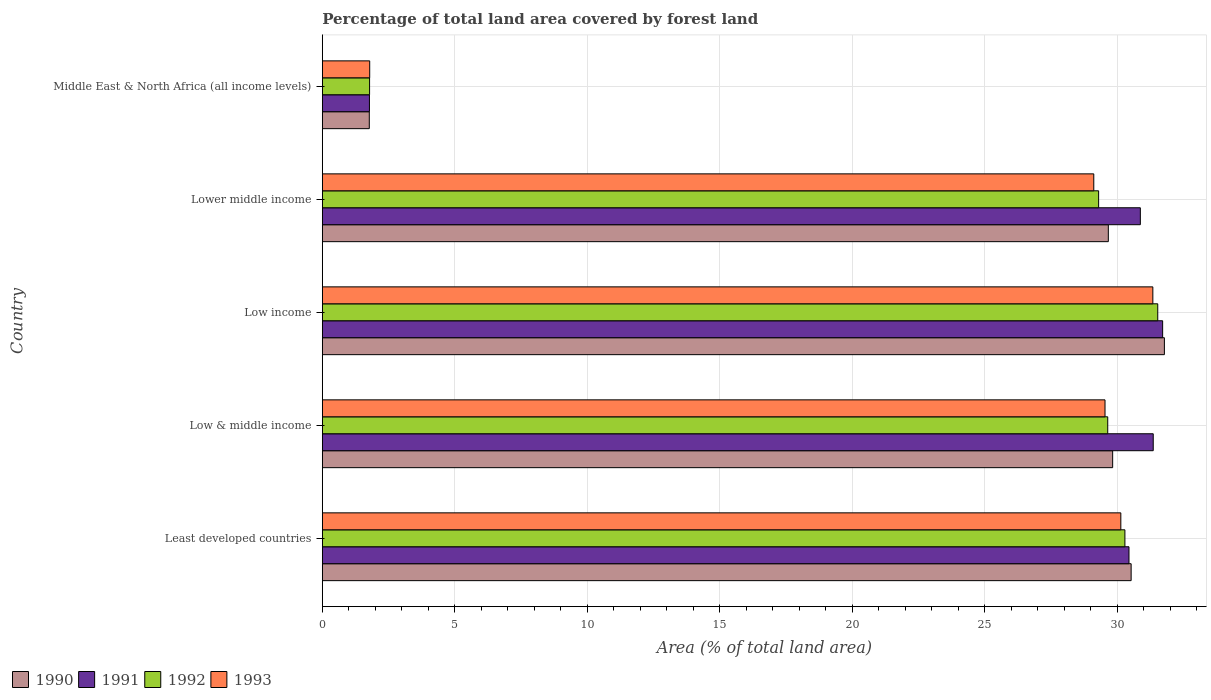Are the number of bars per tick equal to the number of legend labels?
Provide a short and direct response. Yes. Are the number of bars on each tick of the Y-axis equal?
Provide a succinct answer. Yes. How many bars are there on the 4th tick from the top?
Ensure brevity in your answer.  4. How many bars are there on the 3rd tick from the bottom?
Offer a terse response. 4. What is the label of the 5th group of bars from the top?
Your answer should be compact. Least developed countries. In how many cases, is the number of bars for a given country not equal to the number of legend labels?
Offer a terse response. 0. What is the percentage of forest land in 1990 in Low income?
Make the answer very short. 31.79. Across all countries, what is the maximum percentage of forest land in 1991?
Offer a very short reply. 31.72. Across all countries, what is the minimum percentage of forest land in 1993?
Offer a very short reply. 1.79. In which country was the percentage of forest land in 1990 maximum?
Your response must be concise. Low income. In which country was the percentage of forest land in 1990 minimum?
Offer a very short reply. Middle East & North Africa (all income levels). What is the total percentage of forest land in 1990 in the graph?
Offer a very short reply. 123.6. What is the difference between the percentage of forest land in 1993 in Least developed countries and that in Low & middle income?
Keep it short and to the point. 0.6. What is the difference between the percentage of forest land in 1993 in Low income and the percentage of forest land in 1991 in Low & middle income?
Make the answer very short. -0.01. What is the average percentage of forest land in 1992 per country?
Keep it short and to the point. 24.51. What is the difference between the percentage of forest land in 1993 and percentage of forest land in 1990 in Middle East & North Africa (all income levels)?
Make the answer very short. 0.02. In how many countries, is the percentage of forest land in 1993 greater than 29 %?
Provide a short and direct response. 4. What is the ratio of the percentage of forest land in 1991 in Low & middle income to that in Low income?
Offer a very short reply. 0.99. Is the difference between the percentage of forest land in 1993 in Least developed countries and Middle East & North Africa (all income levels) greater than the difference between the percentage of forest land in 1990 in Least developed countries and Middle East & North Africa (all income levels)?
Keep it short and to the point. No. What is the difference between the highest and the second highest percentage of forest land in 1990?
Give a very brief answer. 1.25. What is the difference between the highest and the lowest percentage of forest land in 1991?
Make the answer very short. 29.94. Is the sum of the percentage of forest land in 1991 in Low & middle income and Lower middle income greater than the maximum percentage of forest land in 1993 across all countries?
Your response must be concise. Yes. Is it the case that in every country, the sum of the percentage of forest land in 1990 and percentage of forest land in 1992 is greater than the sum of percentage of forest land in 1993 and percentage of forest land in 1991?
Your response must be concise. No. What does the 2nd bar from the bottom in Middle East & North Africa (all income levels) represents?
Offer a terse response. 1991. Is it the case that in every country, the sum of the percentage of forest land in 1991 and percentage of forest land in 1990 is greater than the percentage of forest land in 1992?
Offer a very short reply. Yes. How many bars are there?
Offer a terse response. 20. Are all the bars in the graph horizontal?
Your response must be concise. Yes. What is the difference between two consecutive major ticks on the X-axis?
Keep it short and to the point. 5. Are the values on the major ticks of X-axis written in scientific E-notation?
Your answer should be compact. No. Does the graph contain any zero values?
Make the answer very short. No. Does the graph contain grids?
Ensure brevity in your answer.  Yes. How are the legend labels stacked?
Give a very brief answer. Horizontal. What is the title of the graph?
Ensure brevity in your answer.  Percentage of total land area covered by forest land. Does "1980" appear as one of the legend labels in the graph?
Your response must be concise. No. What is the label or title of the X-axis?
Provide a succinct answer. Area (% of total land area). What is the Area (% of total land area) of 1990 in Least developed countries?
Make the answer very short. 30.53. What is the Area (% of total land area) in 1991 in Least developed countries?
Offer a terse response. 30.45. What is the Area (% of total land area) of 1992 in Least developed countries?
Provide a short and direct response. 30.3. What is the Area (% of total land area) in 1993 in Least developed countries?
Give a very brief answer. 30.14. What is the Area (% of total land area) of 1990 in Low & middle income?
Your answer should be very brief. 29.83. What is the Area (% of total land area) in 1991 in Low & middle income?
Offer a terse response. 31.37. What is the Area (% of total land area) of 1992 in Low & middle income?
Offer a terse response. 29.65. What is the Area (% of total land area) of 1993 in Low & middle income?
Your answer should be very brief. 29.55. What is the Area (% of total land area) in 1990 in Low income?
Your response must be concise. 31.79. What is the Area (% of total land area) of 1991 in Low income?
Give a very brief answer. 31.72. What is the Area (% of total land area) of 1992 in Low income?
Your answer should be very brief. 31.54. What is the Area (% of total land area) in 1993 in Low income?
Keep it short and to the point. 31.35. What is the Area (% of total land area) of 1990 in Lower middle income?
Offer a very short reply. 29.67. What is the Area (% of total land area) of 1991 in Lower middle income?
Make the answer very short. 30.88. What is the Area (% of total land area) of 1992 in Lower middle income?
Provide a short and direct response. 29.31. What is the Area (% of total land area) of 1993 in Lower middle income?
Give a very brief answer. 29.12. What is the Area (% of total land area) in 1990 in Middle East & North Africa (all income levels)?
Make the answer very short. 1.77. What is the Area (% of total land area) of 1991 in Middle East & North Africa (all income levels)?
Your response must be concise. 1.78. What is the Area (% of total land area) in 1992 in Middle East & North Africa (all income levels)?
Your response must be concise. 1.78. What is the Area (% of total land area) in 1993 in Middle East & North Africa (all income levels)?
Offer a very short reply. 1.79. Across all countries, what is the maximum Area (% of total land area) in 1990?
Ensure brevity in your answer.  31.79. Across all countries, what is the maximum Area (% of total land area) of 1991?
Offer a very short reply. 31.72. Across all countries, what is the maximum Area (% of total land area) of 1992?
Your response must be concise. 31.54. Across all countries, what is the maximum Area (% of total land area) of 1993?
Ensure brevity in your answer.  31.35. Across all countries, what is the minimum Area (% of total land area) of 1990?
Provide a short and direct response. 1.77. Across all countries, what is the minimum Area (% of total land area) of 1991?
Your response must be concise. 1.78. Across all countries, what is the minimum Area (% of total land area) of 1992?
Give a very brief answer. 1.78. Across all countries, what is the minimum Area (% of total land area) of 1993?
Make the answer very short. 1.79. What is the total Area (% of total land area) in 1990 in the graph?
Give a very brief answer. 123.6. What is the total Area (% of total land area) of 1991 in the graph?
Provide a succinct answer. 126.2. What is the total Area (% of total land area) in 1992 in the graph?
Offer a very short reply. 122.57. What is the total Area (% of total land area) of 1993 in the graph?
Make the answer very short. 121.95. What is the difference between the Area (% of total land area) of 1990 in Least developed countries and that in Low & middle income?
Give a very brief answer. 0.7. What is the difference between the Area (% of total land area) of 1991 in Least developed countries and that in Low & middle income?
Ensure brevity in your answer.  -0.92. What is the difference between the Area (% of total land area) in 1992 in Least developed countries and that in Low & middle income?
Provide a succinct answer. 0.65. What is the difference between the Area (% of total land area) of 1993 in Least developed countries and that in Low & middle income?
Keep it short and to the point. 0.6. What is the difference between the Area (% of total land area) in 1990 in Least developed countries and that in Low income?
Your answer should be compact. -1.25. What is the difference between the Area (% of total land area) in 1991 in Least developed countries and that in Low income?
Provide a succinct answer. -1.27. What is the difference between the Area (% of total land area) in 1992 in Least developed countries and that in Low income?
Provide a short and direct response. -1.24. What is the difference between the Area (% of total land area) in 1993 in Least developed countries and that in Low income?
Offer a terse response. -1.21. What is the difference between the Area (% of total land area) in 1990 in Least developed countries and that in Lower middle income?
Provide a short and direct response. 0.86. What is the difference between the Area (% of total land area) of 1991 in Least developed countries and that in Lower middle income?
Provide a short and direct response. -0.43. What is the difference between the Area (% of total land area) of 1992 in Least developed countries and that in Lower middle income?
Ensure brevity in your answer.  0.99. What is the difference between the Area (% of total land area) of 1993 in Least developed countries and that in Lower middle income?
Make the answer very short. 1.02. What is the difference between the Area (% of total land area) in 1990 in Least developed countries and that in Middle East & North Africa (all income levels)?
Make the answer very short. 28.76. What is the difference between the Area (% of total land area) in 1991 in Least developed countries and that in Middle East & North Africa (all income levels)?
Your answer should be compact. 28.67. What is the difference between the Area (% of total land area) in 1992 in Least developed countries and that in Middle East & North Africa (all income levels)?
Provide a succinct answer. 28.51. What is the difference between the Area (% of total land area) of 1993 in Least developed countries and that in Middle East & North Africa (all income levels)?
Give a very brief answer. 28.35. What is the difference between the Area (% of total land area) of 1990 in Low & middle income and that in Low income?
Your answer should be compact. -1.95. What is the difference between the Area (% of total land area) of 1991 in Low & middle income and that in Low income?
Offer a terse response. -0.35. What is the difference between the Area (% of total land area) of 1992 in Low & middle income and that in Low income?
Offer a very short reply. -1.89. What is the difference between the Area (% of total land area) in 1993 in Low & middle income and that in Low income?
Provide a short and direct response. -1.81. What is the difference between the Area (% of total land area) of 1990 in Low & middle income and that in Lower middle income?
Give a very brief answer. 0.16. What is the difference between the Area (% of total land area) in 1991 in Low & middle income and that in Lower middle income?
Provide a short and direct response. 0.49. What is the difference between the Area (% of total land area) of 1992 in Low & middle income and that in Lower middle income?
Your response must be concise. 0.34. What is the difference between the Area (% of total land area) in 1993 in Low & middle income and that in Lower middle income?
Provide a succinct answer. 0.42. What is the difference between the Area (% of total land area) in 1990 in Low & middle income and that in Middle East & North Africa (all income levels)?
Your response must be concise. 28.06. What is the difference between the Area (% of total land area) of 1991 in Low & middle income and that in Middle East & North Africa (all income levels)?
Offer a terse response. 29.59. What is the difference between the Area (% of total land area) of 1992 in Low & middle income and that in Middle East & North Africa (all income levels)?
Offer a terse response. 27.87. What is the difference between the Area (% of total land area) of 1993 in Low & middle income and that in Middle East & North Africa (all income levels)?
Your answer should be compact. 27.76. What is the difference between the Area (% of total land area) of 1990 in Low income and that in Lower middle income?
Offer a very short reply. 2.12. What is the difference between the Area (% of total land area) of 1991 in Low income and that in Lower middle income?
Make the answer very short. 0.84. What is the difference between the Area (% of total land area) of 1992 in Low income and that in Lower middle income?
Ensure brevity in your answer.  2.23. What is the difference between the Area (% of total land area) in 1993 in Low income and that in Lower middle income?
Provide a short and direct response. 2.23. What is the difference between the Area (% of total land area) of 1990 in Low income and that in Middle East & North Africa (all income levels)?
Provide a short and direct response. 30.01. What is the difference between the Area (% of total land area) in 1991 in Low income and that in Middle East & North Africa (all income levels)?
Provide a succinct answer. 29.94. What is the difference between the Area (% of total land area) of 1992 in Low income and that in Middle East & North Africa (all income levels)?
Your answer should be very brief. 29.75. What is the difference between the Area (% of total land area) in 1993 in Low income and that in Middle East & North Africa (all income levels)?
Give a very brief answer. 29.56. What is the difference between the Area (% of total land area) of 1990 in Lower middle income and that in Middle East & North Africa (all income levels)?
Provide a short and direct response. 27.9. What is the difference between the Area (% of total land area) in 1991 in Lower middle income and that in Middle East & North Africa (all income levels)?
Make the answer very short. 29.1. What is the difference between the Area (% of total land area) of 1992 in Lower middle income and that in Middle East & North Africa (all income levels)?
Your answer should be compact. 27.52. What is the difference between the Area (% of total land area) of 1993 in Lower middle income and that in Middle East & North Africa (all income levels)?
Your answer should be very brief. 27.33. What is the difference between the Area (% of total land area) of 1990 in Least developed countries and the Area (% of total land area) of 1991 in Low & middle income?
Ensure brevity in your answer.  -0.83. What is the difference between the Area (% of total land area) in 1990 in Least developed countries and the Area (% of total land area) in 1992 in Low & middle income?
Your response must be concise. 0.88. What is the difference between the Area (% of total land area) in 1990 in Least developed countries and the Area (% of total land area) in 1993 in Low & middle income?
Ensure brevity in your answer.  0.99. What is the difference between the Area (% of total land area) in 1991 in Least developed countries and the Area (% of total land area) in 1992 in Low & middle income?
Keep it short and to the point. 0.8. What is the difference between the Area (% of total land area) of 1991 in Least developed countries and the Area (% of total land area) of 1993 in Low & middle income?
Keep it short and to the point. 0.91. What is the difference between the Area (% of total land area) of 1992 in Least developed countries and the Area (% of total land area) of 1993 in Low & middle income?
Offer a terse response. 0.75. What is the difference between the Area (% of total land area) of 1990 in Least developed countries and the Area (% of total land area) of 1991 in Low income?
Your answer should be very brief. -1.19. What is the difference between the Area (% of total land area) of 1990 in Least developed countries and the Area (% of total land area) of 1992 in Low income?
Make the answer very short. -1. What is the difference between the Area (% of total land area) of 1990 in Least developed countries and the Area (% of total land area) of 1993 in Low income?
Your response must be concise. -0.82. What is the difference between the Area (% of total land area) of 1991 in Least developed countries and the Area (% of total land area) of 1992 in Low income?
Provide a short and direct response. -1.09. What is the difference between the Area (% of total land area) in 1991 in Least developed countries and the Area (% of total land area) in 1993 in Low income?
Offer a terse response. -0.9. What is the difference between the Area (% of total land area) in 1992 in Least developed countries and the Area (% of total land area) in 1993 in Low income?
Keep it short and to the point. -1.05. What is the difference between the Area (% of total land area) of 1990 in Least developed countries and the Area (% of total land area) of 1991 in Lower middle income?
Provide a succinct answer. -0.35. What is the difference between the Area (% of total land area) in 1990 in Least developed countries and the Area (% of total land area) in 1992 in Lower middle income?
Offer a terse response. 1.23. What is the difference between the Area (% of total land area) of 1990 in Least developed countries and the Area (% of total land area) of 1993 in Lower middle income?
Make the answer very short. 1.41. What is the difference between the Area (% of total land area) in 1991 in Least developed countries and the Area (% of total land area) in 1992 in Lower middle income?
Offer a very short reply. 1.15. What is the difference between the Area (% of total land area) of 1991 in Least developed countries and the Area (% of total land area) of 1993 in Lower middle income?
Provide a short and direct response. 1.33. What is the difference between the Area (% of total land area) in 1992 in Least developed countries and the Area (% of total land area) in 1993 in Lower middle income?
Make the answer very short. 1.18. What is the difference between the Area (% of total land area) in 1990 in Least developed countries and the Area (% of total land area) in 1991 in Middle East & North Africa (all income levels)?
Provide a short and direct response. 28.75. What is the difference between the Area (% of total land area) in 1990 in Least developed countries and the Area (% of total land area) in 1992 in Middle East & North Africa (all income levels)?
Ensure brevity in your answer.  28.75. What is the difference between the Area (% of total land area) of 1990 in Least developed countries and the Area (% of total land area) of 1993 in Middle East & North Africa (all income levels)?
Keep it short and to the point. 28.74. What is the difference between the Area (% of total land area) in 1991 in Least developed countries and the Area (% of total land area) in 1992 in Middle East & North Africa (all income levels)?
Ensure brevity in your answer.  28.67. What is the difference between the Area (% of total land area) of 1991 in Least developed countries and the Area (% of total land area) of 1993 in Middle East & North Africa (all income levels)?
Offer a very short reply. 28.66. What is the difference between the Area (% of total land area) in 1992 in Least developed countries and the Area (% of total land area) in 1993 in Middle East & North Africa (all income levels)?
Your response must be concise. 28.51. What is the difference between the Area (% of total land area) in 1990 in Low & middle income and the Area (% of total land area) in 1991 in Low income?
Offer a terse response. -1.89. What is the difference between the Area (% of total land area) in 1990 in Low & middle income and the Area (% of total land area) in 1992 in Low income?
Provide a short and direct response. -1.7. What is the difference between the Area (% of total land area) of 1990 in Low & middle income and the Area (% of total land area) of 1993 in Low income?
Your answer should be compact. -1.52. What is the difference between the Area (% of total land area) of 1991 in Low & middle income and the Area (% of total land area) of 1992 in Low income?
Offer a terse response. -0.17. What is the difference between the Area (% of total land area) in 1991 in Low & middle income and the Area (% of total land area) in 1993 in Low income?
Make the answer very short. 0.01. What is the difference between the Area (% of total land area) in 1992 in Low & middle income and the Area (% of total land area) in 1993 in Low income?
Provide a short and direct response. -1.7. What is the difference between the Area (% of total land area) of 1990 in Low & middle income and the Area (% of total land area) of 1991 in Lower middle income?
Provide a succinct answer. -1.05. What is the difference between the Area (% of total land area) in 1990 in Low & middle income and the Area (% of total land area) in 1992 in Lower middle income?
Give a very brief answer. 0.53. What is the difference between the Area (% of total land area) in 1990 in Low & middle income and the Area (% of total land area) in 1993 in Lower middle income?
Make the answer very short. 0.71. What is the difference between the Area (% of total land area) in 1991 in Low & middle income and the Area (% of total land area) in 1992 in Lower middle income?
Ensure brevity in your answer.  2.06. What is the difference between the Area (% of total land area) in 1991 in Low & middle income and the Area (% of total land area) in 1993 in Lower middle income?
Your response must be concise. 2.24. What is the difference between the Area (% of total land area) of 1992 in Low & middle income and the Area (% of total land area) of 1993 in Lower middle income?
Offer a terse response. 0.53. What is the difference between the Area (% of total land area) in 1990 in Low & middle income and the Area (% of total land area) in 1991 in Middle East & North Africa (all income levels)?
Offer a very short reply. 28.06. What is the difference between the Area (% of total land area) in 1990 in Low & middle income and the Area (% of total land area) in 1992 in Middle East & North Africa (all income levels)?
Give a very brief answer. 28.05. What is the difference between the Area (% of total land area) of 1990 in Low & middle income and the Area (% of total land area) of 1993 in Middle East & North Africa (all income levels)?
Ensure brevity in your answer.  28.05. What is the difference between the Area (% of total land area) in 1991 in Low & middle income and the Area (% of total land area) in 1992 in Middle East & North Africa (all income levels)?
Keep it short and to the point. 29.58. What is the difference between the Area (% of total land area) in 1991 in Low & middle income and the Area (% of total land area) in 1993 in Middle East & North Africa (all income levels)?
Your response must be concise. 29.58. What is the difference between the Area (% of total land area) of 1992 in Low & middle income and the Area (% of total land area) of 1993 in Middle East & North Africa (all income levels)?
Make the answer very short. 27.86. What is the difference between the Area (% of total land area) in 1990 in Low income and the Area (% of total land area) in 1991 in Lower middle income?
Give a very brief answer. 0.91. What is the difference between the Area (% of total land area) of 1990 in Low income and the Area (% of total land area) of 1992 in Lower middle income?
Ensure brevity in your answer.  2.48. What is the difference between the Area (% of total land area) in 1990 in Low income and the Area (% of total land area) in 1993 in Lower middle income?
Offer a very short reply. 2.67. What is the difference between the Area (% of total land area) of 1991 in Low income and the Area (% of total land area) of 1992 in Lower middle income?
Provide a short and direct response. 2.42. What is the difference between the Area (% of total land area) of 1991 in Low income and the Area (% of total land area) of 1993 in Lower middle income?
Your answer should be compact. 2.6. What is the difference between the Area (% of total land area) in 1992 in Low income and the Area (% of total land area) in 1993 in Lower middle income?
Your answer should be very brief. 2.41. What is the difference between the Area (% of total land area) in 1990 in Low income and the Area (% of total land area) in 1991 in Middle East & North Africa (all income levels)?
Ensure brevity in your answer.  30.01. What is the difference between the Area (% of total land area) in 1990 in Low income and the Area (% of total land area) in 1992 in Middle East & North Africa (all income levels)?
Ensure brevity in your answer.  30. What is the difference between the Area (% of total land area) of 1990 in Low income and the Area (% of total land area) of 1993 in Middle East & North Africa (all income levels)?
Your answer should be very brief. 30. What is the difference between the Area (% of total land area) in 1991 in Low income and the Area (% of total land area) in 1992 in Middle East & North Africa (all income levels)?
Offer a terse response. 29.94. What is the difference between the Area (% of total land area) of 1991 in Low income and the Area (% of total land area) of 1993 in Middle East & North Africa (all income levels)?
Your response must be concise. 29.93. What is the difference between the Area (% of total land area) in 1992 in Low income and the Area (% of total land area) in 1993 in Middle East & North Africa (all income levels)?
Your answer should be compact. 29.75. What is the difference between the Area (% of total land area) in 1990 in Lower middle income and the Area (% of total land area) in 1991 in Middle East & North Africa (all income levels)?
Provide a short and direct response. 27.89. What is the difference between the Area (% of total land area) in 1990 in Lower middle income and the Area (% of total land area) in 1992 in Middle East & North Africa (all income levels)?
Ensure brevity in your answer.  27.89. What is the difference between the Area (% of total land area) of 1990 in Lower middle income and the Area (% of total land area) of 1993 in Middle East & North Africa (all income levels)?
Provide a succinct answer. 27.88. What is the difference between the Area (% of total land area) of 1991 in Lower middle income and the Area (% of total land area) of 1992 in Middle East & North Africa (all income levels)?
Keep it short and to the point. 29.1. What is the difference between the Area (% of total land area) of 1991 in Lower middle income and the Area (% of total land area) of 1993 in Middle East & North Africa (all income levels)?
Offer a terse response. 29.09. What is the difference between the Area (% of total land area) in 1992 in Lower middle income and the Area (% of total land area) in 1993 in Middle East & North Africa (all income levels)?
Provide a succinct answer. 27.52. What is the average Area (% of total land area) of 1990 per country?
Provide a short and direct response. 24.72. What is the average Area (% of total land area) in 1991 per country?
Ensure brevity in your answer.  25.24. What is the average Area (% of total land area) in 1992 per country?
Make the answer very short. 24.51. What is the average Area (% of total land area) in 1993 per country?
Your response must be concise. 24.39. What is the difference between the Area (% of total land area) in 1990 and Area (% of total land area) in 1991 in Least developed countries?
Your answer should be compact. 0.08. What is the difference between the Area (% of total land area) of 1990 and Area (% of total land area) of 1992 in Least developed countries?
Keep it short and to the point. 0.24. What is the difference between the Area (% of total land area) in 1990 and Area (% of total land area) in 1993 in Least developed countries?
Your answer should be very brief. 0.39. What is the difference between the Area (% of total land area) in 1991 and Area (% of total land area) in 1992 in Least developed countries?
Your answer should be very brief. 0.15. What is the difference between the Area (% of total land area) in 1991 and Area (% of total land area) in 1993 in Least developed countries?
Give a very brief answer. 0.31. What is the difference between the Area (% of total land area) in 1992 and Area (% of total land area) in 1993 in Least developed countries?
Make the answer very short. 0.15. What is the difference between the Area (% of total land area) of 1990 and Area (% of total land area) of 1991 in Low & middle income?
Offer a very short reply. -1.53. What is the difference between the Area (% of total land area) in 1990 and Area (% of total land area) in 1992 in Low & middle income?
Give a very brief answer. 0.19. What is the difference between the Area (% of total land area) in 1990 and Area (% of total land area) in 1993 in Low & middle income?
Keep it short and to the point. 0.29. What is the difference between the Area (% of total land area) in 1991 and Area (% of total land area) in 1992 in Low & middle income?
Make the answer very short. 1.72. What is the difference between the Area (% of total land area) of 1991 and Area (% of total land area) of 1993 in Low & middle income?
Make the answer very short. 1.82. What is the difference between the Area (% of total land area) in 1992 and Area (% of total land area) in 1993 in Low & middle income?
Your answer should be very brief. 0.1. What is the difference between the Area (% of total land area) of 1990 and Area (% of total land area) of 1991 in Low income?
Give a very brief answer. 0.07. What is the difference between the Area (% of total land area) of 1990 and Area (% of total land area) of 1992 in Low income?
Ensure brevity in your answer.  0.25. What is the difference between the Area (% of total land area) of 1990 and Area (% of total land area) of 1993 in Low income?
Give a very brief answer. 0.44. What is the difference between the Area (% of total land area) of 1991 and Area (% of total land area) of 1992 in Low income?
Ensure brevity in your answer.  0.18. What is the difference between the Area (% of total land area) of 1991 and Area (% of total land area) of 1993 in Low income?
Offer a terse response. 0.37. What is the difference between the Area (% of total land area) in 1992 and Area (% of total land area) in 1993 in Low income?
Make the answer very short. 0.18. What is the difference between the Area (% of total land area) in 1990 and Area (% of total land area) in 1991 in Lower middle income?
Offer a very short reply. -1.21. What is the difference between the Area (% of total land area) in 1990 and Area (% of total land area) in 1992 in Lower middle income?
Provide a succinct answer. 0.37. What is the difference between the Area (% of total land area) of 1990 and Area (% of total land area) of 1993 in Lower middle income?
Your answer should be very brief. 0.55. What is the difference between the Area (% of total land area) in 1991 and Area (% of total land area) in 1992 in Lower middle income?
Provide a short and direct response. 1.57. What is the difference between the Area (% of total land area) of 1991 and Area (% of total land area) of 1993 in Lower middle income?
Provide a succinct answer. 1.76. What is the difference between the Area (% of total land area) in 1992 and Area (% of total land area) in 1993 in Lower middle income?
Keep it short and to the point. 0.18. What is the difference between the Area (% of total land area) in 1990 and Area (% of total land area) in 1991 in Middle East & North Africa (all income levels)?
Provide a short and direct response. -0.01. What is the difference between the Area (% of total land area) in 1990 and Area (% of total land area) in 1992 in Middle East & North Africa (all income levels)?
Keep it short and to the point. -0.01. What is the difference between the Area (% of total land area) in 1990 and Area (% of total land area) in 1993 in Middle East & North Africa (all income levels)?
Make the answer very short. -0.02. What is the difference between the Area (% of total land area) of 1991 and Area (% of total land area) of 1992 in Middle East & North Africa (all income levels)?
Provide a short and direct response. -0.01. What is the difference between the Area (% of total land area) in 1991 and Area (% of total land area) in 1993 in Middle East & North Africa (all income levels)?
Your answer should be compact. -0.01. What is the difference between the Area (% of total land area) in 1992 and Area (% of total land area) in 1993 in Middle East & North Africa (all income levels)?
Offer a terse response. -0.01. What is the ratio of the Area (% of total land area) in 1990 in Least developed countries to that in Low & middle income?
Make the answer very short. 1.02. What is the ratio of the Area (% of total land area) of 1991 in Least developed countries to that in Low & middle income?
Make the answer very short. 0.97. What is the ratio of the Area (% of total land area) in 1992 in Least developed countries to that in Low & middle income?
Offer a very short reply. 1.02. What is the ratio of the Area (% of total land area) in 1993 in Least developed countries to that in Low & middle income?
Keep it short and to the point. 1.02. What is the ratio of the Area (% of total land area) of 1990 in Least developed countries to that in Low income?
Ensure brevity in your answer.  0.96. What is the ratio of the Area (% of total land area) of 1991 in Least developed countries to that in Low income?
Make the answer very short. 0.96. What is the ratio of the Area (% of total land area) in 1992 in Least developed countries to that in Low income?
Offer a very short reply. 0.96. What is the ratio of the Area (% of total land area) in 1993 in Least developed countries to that in Low income?
Give a very brief answer. 0.96. What is the ratio of the Area (% of total land area) in 1990 in Least developed countries to that in Lower middle income?
Your answer should be compact. 1.03. What is the ratio of the Area (% of total land area) of 1991 in Least developed countries to that in Lower middle income?
Offer a terse response. 0.99. What is the ratio of the Area (% of total land area) in 1992 in Least developed countries to that in Lower middle income?
Your response must be concise. 1.03. What is the ratio of the Area (% of total land area) in 1993 in Least developed countries to that in Lower middle income?
Keep it short and to the point. 1.04. What is the ratio of the Area (% of total land area) in 1990 in Least developed countries to that in Middle East & North Africa (all income levels)?
Provide a succinct answer. 17.22. What is the ratio of the Area (% of total land area) of 1991 in Least developed countries to that in Middle East & North Africa (all income levels)?
Your response must be concise. 17.12. What is the ratio of the Area (% of total land area) of 1992 in Least developed countries to that in Middle East & North Africa (all income levels)?
Offer a terse response. 16.99. What is the ratio of the Area (% of total land area) of 1993 in Least developed countries to that in Middle East & North Africa (all income levels)?
Your answer should be compact. 16.85. What is the ratio of the Area (% of total land area) of 1990 in Low & middle income to that in Low income?
Make the answer very short. 0.94. What is the ratio of the Area (% of total land area) of 1991 in Low & middle income to that in Low income?
Ensure brevity in your answer.  0.99. What is the ratio of the Area (% of total land area) in 1992 in Low & middle income to that in Low income?
Your answer should be very brief. 0.94. What is the ratio of the Area (% of total land area) of 1993 in Low & middle income to that in Low income?
Offer a very short reply. 0.94. What is the ratio of the Area (% of total land area) in 1991 in Low & middle income to that in Lower middle income?
Your response must be concise. 1.02. What is the ratio of the Area (% of total land area) in 1992 in Low & middle income to that in Lower middle income?
Your answer should be compact. 1.01. What is the ratio of the Area (% of total land area) in 1993 in Low & middle income to that in Lower middle income?
Give a very brief answer. 1.01. What is the ratio of the Area (% of total land area) in 1990 in Low & middle income to that in Middle East & North Africa (all income levels)?
Ensure brevity in your answer.  16.82. What is the ratio of the Area (% of total land area) in 1991 in Low & middle income to that in Middle East & North Africa (all income levels)?
Your answer should be very brief. 17.64. What is the ratio of the Area (% of total land area) in 1992 in Low & middle income to that in Middle East & North Africa (all income levels)?
Ensure brevity in your answer.  16.62. What is the ratio of the Area (% of total land area) of 1993 in Low & middle income to that in Middle East & North Africa (all income levels)?
Offer a very short reply. 16.52. What is the ratio of the Area (% of total land area) of 1990 in Low income to that in Lower middle income?
Your answer should be compact. 1.07. What is the ratio of the Area (% of total land area) of 1991 in Low income to that in Lower middle income?
Make the answer very short. 1.03. What is the ratio of the Area (% of total land area) in 1992 in Low income to that in Lower middle income?
Provide a short and direct response. 1.08. What is the ratio of the Area (% of total land area) of 1993 in Low income to that in Lower middle income?
Ensure brevity in your answer.  1.08. What is the ratio of the Area (% of total land area) in 1990 in Low income to that in Middle East & North Africa (all income levels)?
Ensure brevity in your answer.  17.93. What is the ratio of the Area (% of total land area) of 1991 in Low income to that in Middle East & North Africa (all income levels)?
Provide a succinct answer. 17.84. What is the ratio of the Area (% of total land area) in 1992 in Low income to that in Middle East & North Africa (all income levels)?
Offer a terse response. 17.68. What is the ratio of the Area (% of total land area) of 1993 in Low income to that in Middle East & North Africa (all income levels)?
Offer a very short reply. 17.53. What is the ratio of the Area (% of total land area) in 1990 in Lower middle income to that in Middle East & North Africa (all income levels)?
Make the answer very short. 16.73. What is the ratio of the Area (% of total land area) of 1991 in Lower middle income to that in Middle East & North Africa (all income levels)?
Your response must be concise. 17.36. What is the ratio of the Area (% of total land area) in 1992 in Lower middle income to that in Middle East & North Africa (all income levels)?
Provide a short and direct response. 16.43. What is the ratio of the Area (% of total land area) of 1993 in Lower middle income to that in Middle East & North Africa (all income levels)?
Make the answer very short. 16.28. What is the difference between the highest and the second highest Area (% of total land area) of 1990?
Your response must be concise. 1.25. What is the difference between the highest and the second highest Area (% of total land area) of 1991?
Give a very brief answer. 0.35. What is the difference between the highest and the second highest Area (% of total land area) of 1992?
Provide a short and direct response. 1.24. What is the difference between the highest and the second highest Area (% of total land area) of 1993?
Ensure brevity in your answer.  1.21. What is the difference between the highest and the lowest Area (% of total land area) of 1990?
Make the answer very short. 30.01. What is the difference between the highest and the lowest Area (% of total land area) of 1991?
Offer a terse response. 29.94. What is the difference between the highest and the lowest Area (% of total land area) in 1992?
Your answer should be compact. 29.75. What is the difference between the highest and the lowest Area (% of total land area) of 1993?
Ensure brevity in your answer.  29.56. 